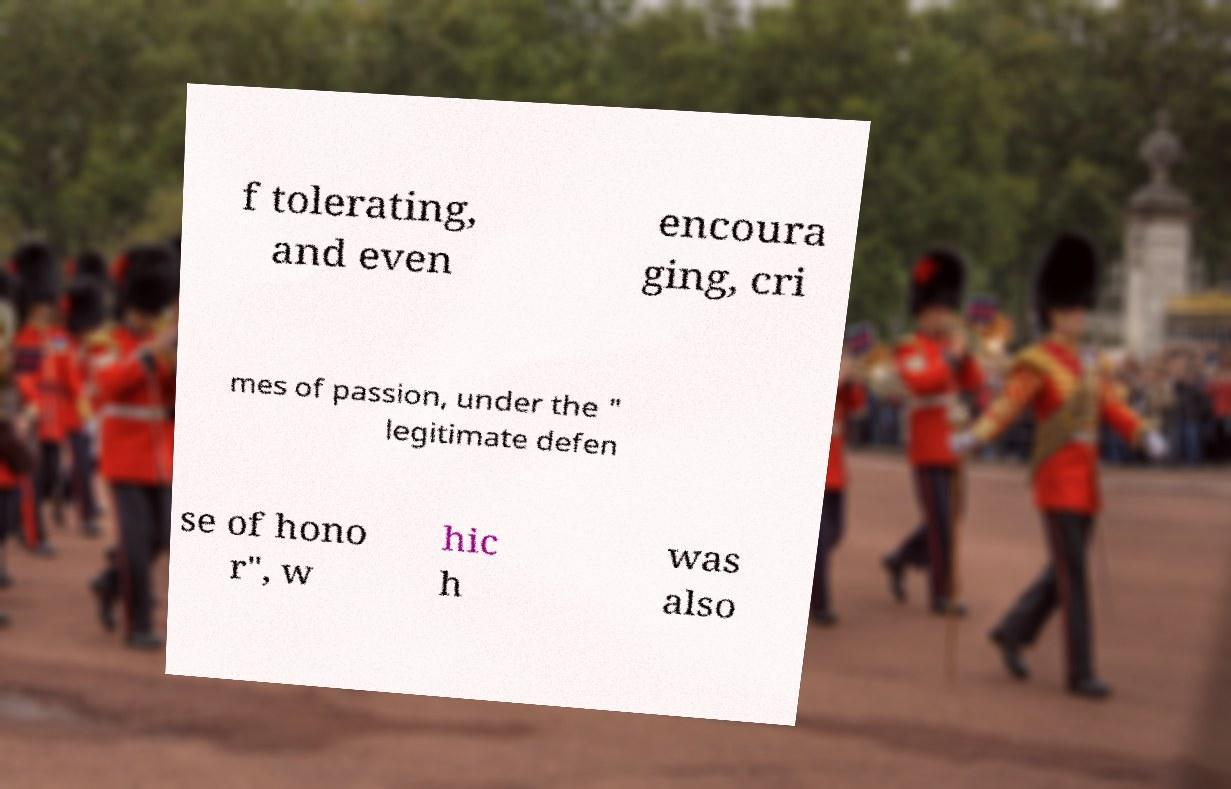Please identify and transcribe the text found in this image. f tolerating, and even encoura ging, cri mes of passion, under the " legitimate defen se of hono r", w hic h was also 